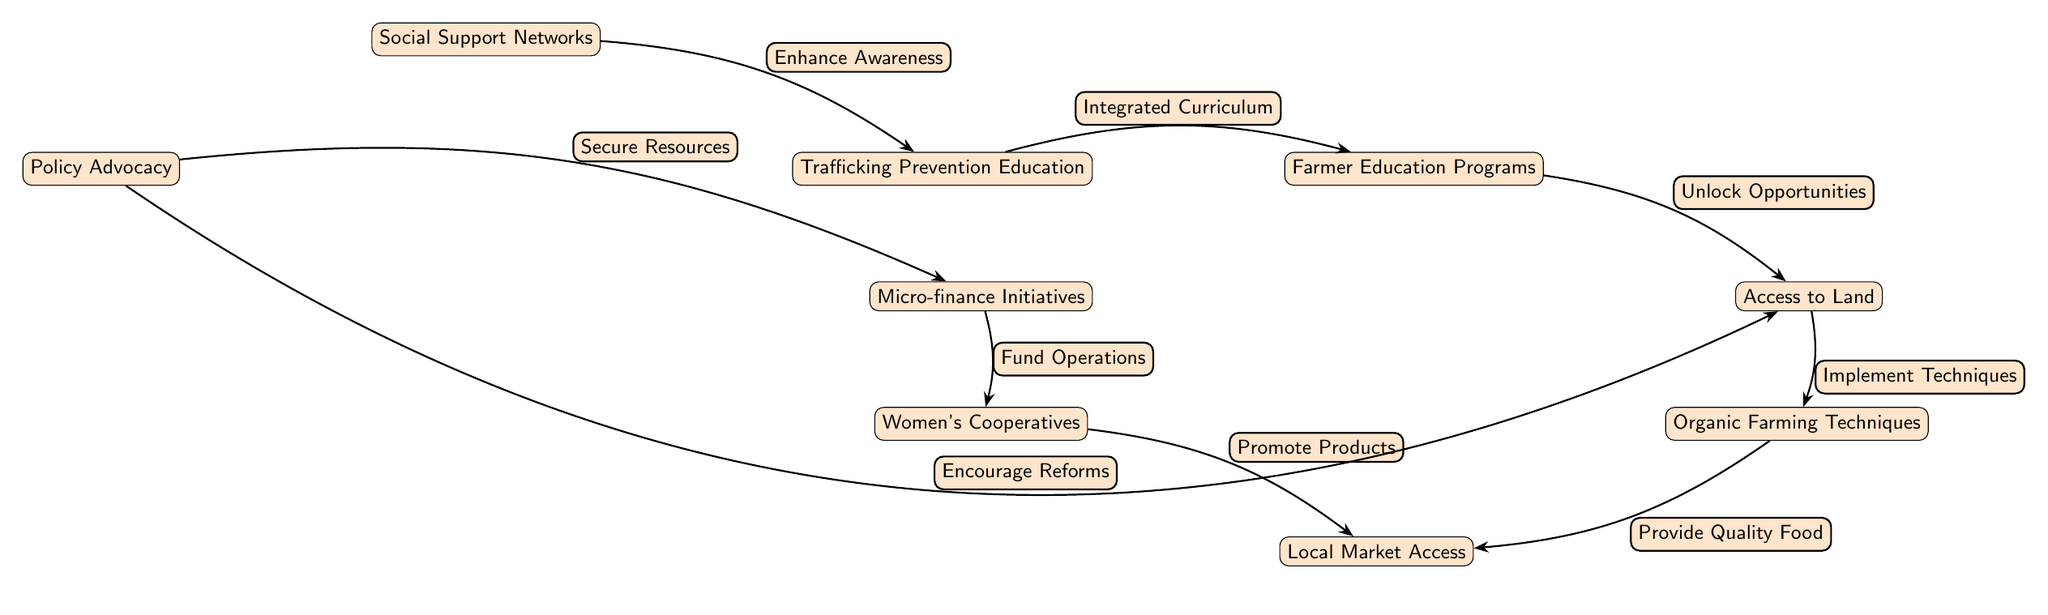What is at the top of the diagram? The top node in the diagram is titled "Farmer Education Programs," which represents the starting point for various initiatives in sustainable farming practices.
Answer: Farmer Education Programs How many main nodes are there in the diagram? By counting all distinct nodes in the diagram, we find that there are eight main nodes representing various aspects of sustainable farming and trafficking prevention.
Answer: 8 What edge connects "Farmer Education Programs" and "Trafficking Prevention Education"? The edge labeled "Integrated Curriculum" connects these two nodes, indicating a relationship wherein education on trafficking is integrated into farming programs.
Answer: Integrated Curriculum What type of support is represented by the edge leading from "Social Support Networks"? The edge labeled "Enhance Awareness" signifies that social support networks improve awareness regarding trafficking prevention in the context of farming.
Answer: Enhance Awareness Which node does "Policy Advocacy" connect to that involves financial aspects? "Policy Advocacy" connects to the "Micro-finance Initiatives" node, which pertains to funding and financial support for farmers and cooperatives.
Answer: Micro-finance Initiatives Explain how "Women's Cooperatives" contribute to "Local Market Access." The edge labeled "Promote Products" indicates that the activities of women's cooperatives help in potentially increasing access to local markets by promoting their products effectively.
Answer: Promote Products What is the significance of "Organic Farming Techniques" in relation to "Local Market Access"? The edge labeled "Provide Quality Food" signifies that using organic farming techniques leads to higher quality food products, which can improve local market access due to increased consumer demand.
Answer: Provide Quality Food How does "Micro-finance Initiatives" relate to "Women's Cooperatives"? The edge labeled "Fund Operations" reveals that micro-finance initiatives provide necessary funding that enables women's cooperatives to operate effectively.
Answer: Fund Operations What is the outcome of "Access to Land" after "Farmer Education Programs"? The edge labeled "Unlock Opportunities" suggests that access to land is facilitated or improved as a result of the farmer education programs, creating more opportunities for sustainable farming.
Answer: Unlock Opportunities 